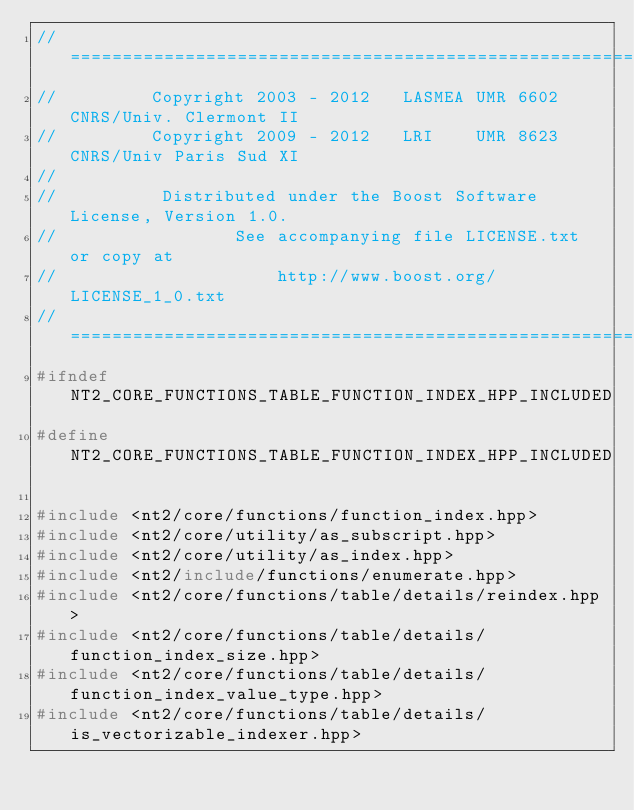Convert code to text. <code><loc_0><loc_0><loc_500><loc_500><_C++_>//==============================================================================
//         Copyright 2003 - 2012   LASMEA UMR 6602 CNRS/Univ. Clermont II
//         Copyright 2009 - 2012   LRI    UMR 8623 CNRS/Univ Paris Sud XI
//
//          Distributed under the Boost Software License, Version 1.0.
//                 See accompanying file LICENSE.txt or copy at
//                     http://www.boost.org/LICENSE_1_0.txt
//==============================================================================
#ifndef NT2_CORE_FUNCTIONS_TABLE_FUNCTION_INDEX_HPP_INCLUDED
#define NT2_CORE_FUNCTIONS_TABLE_FUNCTION_INDEX_HPP_INCLUDED

#include <nt2/core/functions/function_index.hpp>
#include <nt2/core/utility/as_subscript.hpp>
#include <nt2/core/utility/as_index.hpp>
#include <nt2/include/functions/enumerate.hpp>
#include <nt2/core/functions/table/details/reindex.hpp>
#include <nt2/core/functions/table/details/function_index_size.hpp>
#include <nt2/core/functions/table/details/function_index_value_type.hpp>
#include <nt2/core/functions/table/details/is_vectorizable_indexer.hpp></code> 